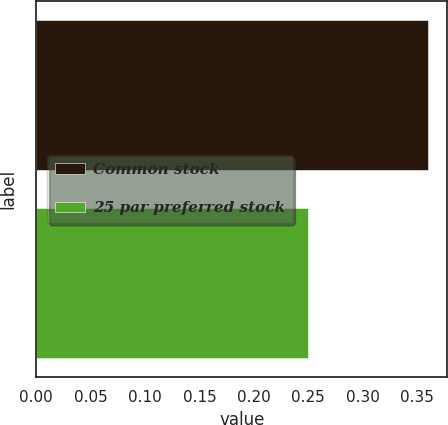<chart> <loc_0><loc_0><loc_500><loc_500><bar_chart><fcel>Common stock<fcel>25 par preferred stock<nl><fcel>0.36<fcel>0.25<nl></chart> 